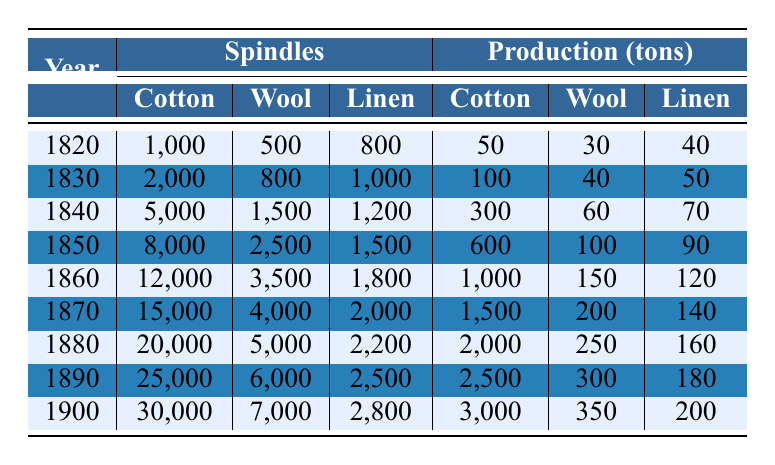What was the total production of cotton in 1840? The table states that cotton production in 1840 was 300 tons, which is the specific value referenced.
Answer: 300 tons How many wool spindles were there in 1850? The table shows that the number of wool spindles in 1850 was 2500, which is directly listed.
Answer: 2500 In which year did cotton spindles exceed 15,000? Looking at the table, cotton spindles exceeded 15,000 for the first time in 1870, as evidenced by the figures provided.
Answer: 1870 What is the average production of linen from 1820 to 1900? The total production of linen from 1820 to 1900 is calculated by summing the production from each year: (40 + 50 + 70 + 90 + 120 + 140 + 160 + 180 + 200) = 1,100 tons. There are 9 data points, so the average is 1100/9 = 122.22 tons, which rounds to approximately 122 tons.
Answer: 122 tons Is the total cotton production in the 1890s greater than that in the 1880s? In the 1880s, the cotton production was 2000 tons in 1880 and 2500 tons in 1890 (max value), totaling 4500 tons. In the 1890s, the only year listed is 1900 with 3000 tons. 4500 tons is greater than 3000 tons.
Answer: No Which year had the highest wool production, and how many tons were produced? By reviewing the table, the year with the highest wool production is 1900 with 350 tons. This is seen directly from the figures.
Answer: 1900, 350 tons What is the ratio of cotton production to wool production in the year 1870? The cotton production in 1870 was 1500 tons and wool production was 200 tons. The ratio is calculated as 1500/200 = 7.5.
Answer: 7.5 Did the number of wool spindles show an increasing trend from 1820 to 1900? By examining the table, the number of wool spindles increased every decade: 500 in 1820, 800 in 1830, 1500 in 1840, 2500 in 1850, 3500 in 1860, 4000 in 1870, 5000 in 1880, 6000 in 1890, and 7000 in 1900. This confirms an overall increasing trend.
Answer: Yes What was the change in cotton spindle count from 1860 to 1900? Cotton spindles in 1860 were 12000, and in 1900 they were 30000. The change is calculated as 30000 - 12000 = 18000.
Answer: 18000 